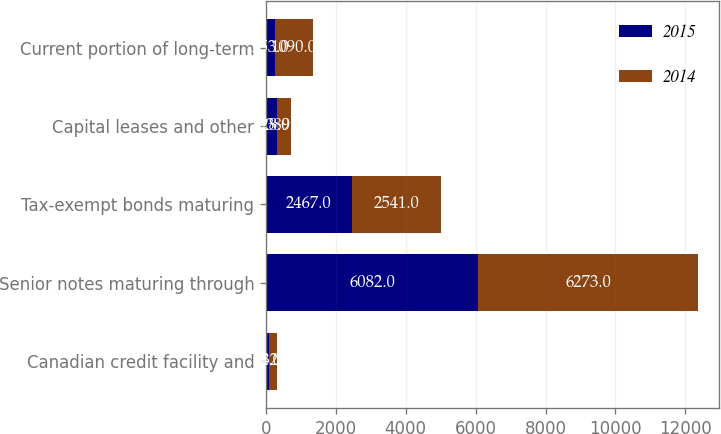<chart> <loc_0><loc_0><loc_500><loc_500><stacked_bar_chart><ecel><fcel>Canadian credit facility and<fcel>Senior notes maturing through<fcel>Tax-exempt bonds maturing<fcel>Capital leases and other<fcel>Current portion of long-term<nl><fcel>2015<fcel>84<fcel>6082<fcel>2467<fcel>328<fcel>253<nl><fcel>2014<fcel>232<fcel>6273<fcel>2541<fcel>389<fcel>1090<nl></chart> 